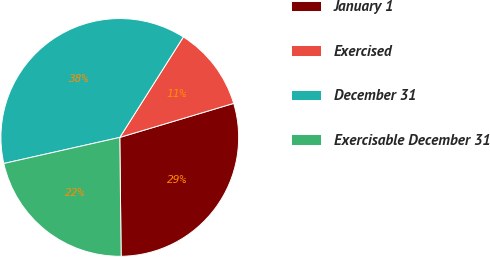<chart> <loc_0><loc_0><loc_500><loc_500><pie_chart><fcel>January 1<fcel>Exercised<fcel>December 31<fcel>Exercisable December 31<nl><fcel>29.44%<fcel>11.4%<fcel>37.5%<fcel>21.66%<nl></chart> 